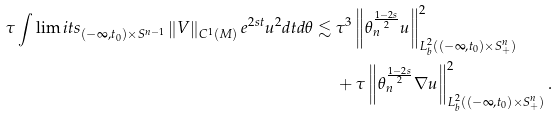<formula> <loc_0><loc_0><loc_500><loc_500>\tau \int \lim i t s _ { ( - \infty , t _ { 0 } ) \times S ^ { n - 1 } } \left \| V \right \| _ { C ^ { 1 } ( M ) } e ^ { 2 s t } u ^ { 2 } d t d \theta \lesssim & \ \tau ^ { 3 } \left \| \theta _ { n } ^ { \frac { 1 - 2 s } { 2 } } u \right \| _ { L ^ { 2 } _ { b } ( ( - \infty , t _ { 0 } ) \times S ^ { n } _ { + } ) } ^ { 2 } \\ & \ + \tau \left \| \theta _ { n } ^ { \frac { 1 - 2 s } { 2 } } \nabla u \right \| _ { L ^ { 2 } _ { b } ( ( - \infty , t _ { 0 } ) \times S ^ { n } _ { + } ) } ^ { 2 } .</formula> 